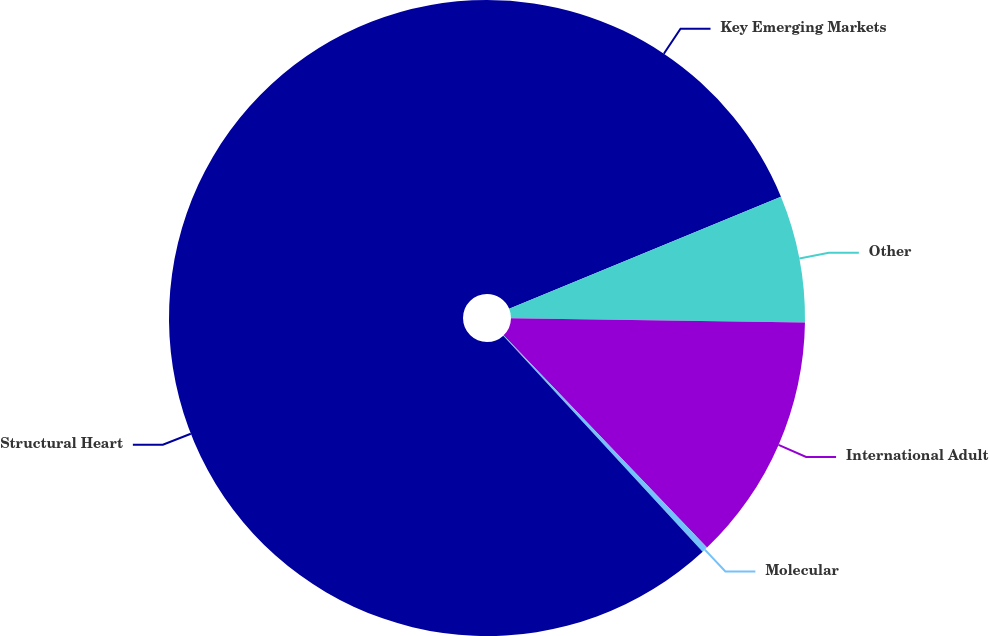Convert chart. <chart><loc_0><loc_0><loc_500><loc_500><pie_chart><fcel>Key Emerging Markets<fcel>Other<fcel>International Adult<fcel>Molecular<fcel>Structural Heart<nl><fcel>18.77%<fcel>6.46%<fcel>12.61%<fcel>0.3%<fcel>61.86%<nl></chart> 